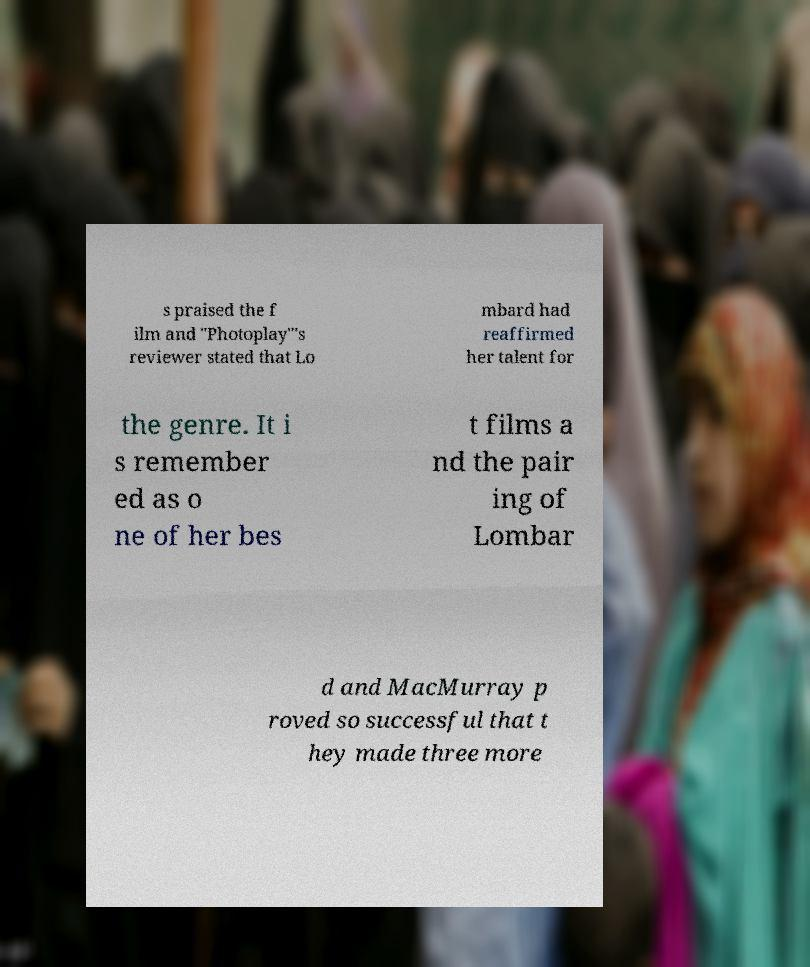Please identify and transcribe the text found in this image. s praised the f ilm and "Photoplay"'s reviewer stated that Lo mbard had reaffirmed her talent for the genre. It i s remember ed as o ne of her bes t films a nd the pair ing of Lombar d and MacMurray p roved so successful that t hey made three more 